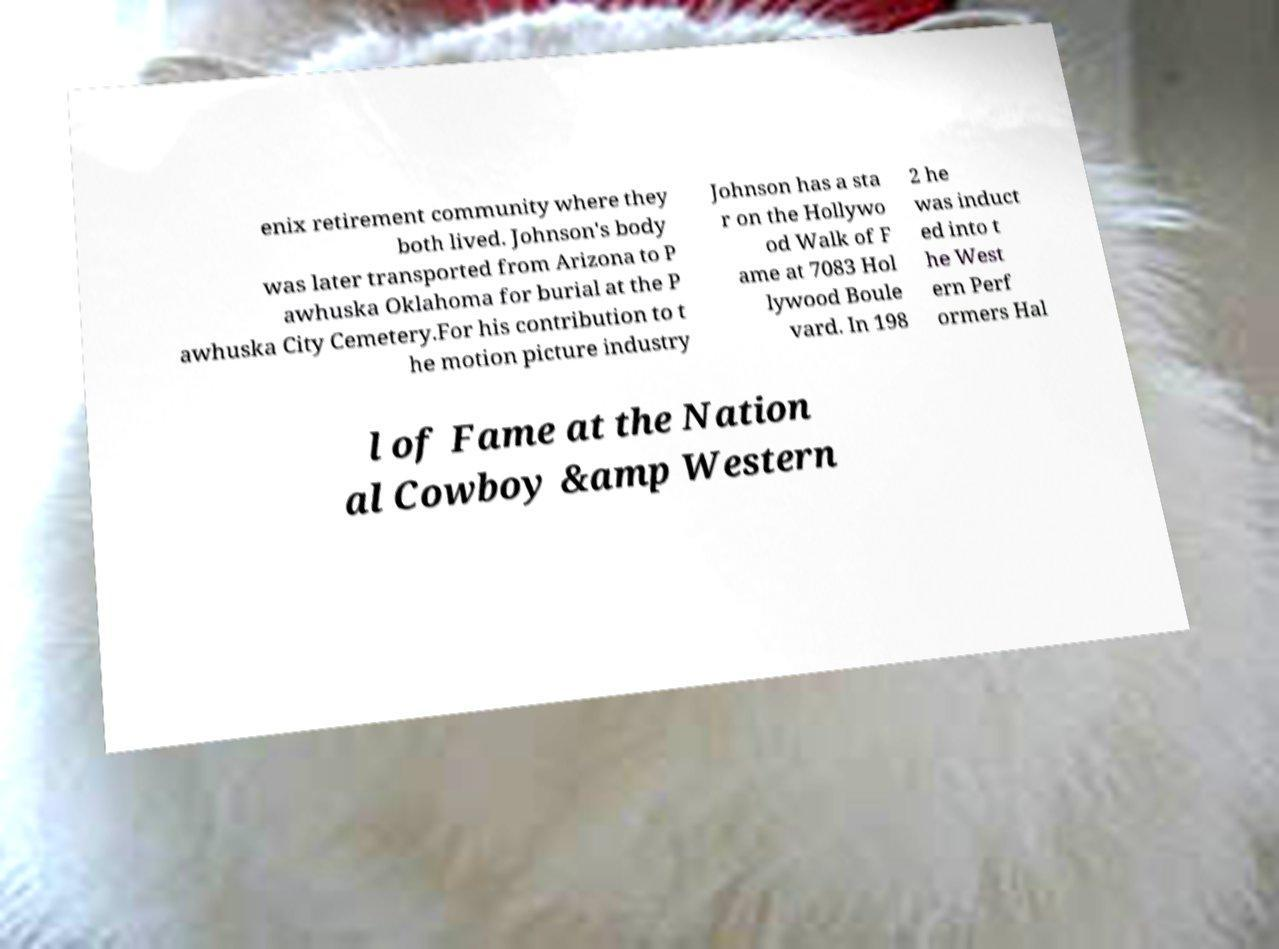I need the written content from this picture converted into text. Can you do that? enix retirement community where they both lived. Johnson's body was later transported from Arizona to P awhuska Oklahoma for burial at the P awhuska City Cemetery.For his contribution to t he motion picture industry Johnson has a sta r on the Hollywo od Walk of F ame at 7083 Hol lywood Boule vard. In 198 2 he was induct ed into t he West ern Perf ormers Hal l of Fame at the Nation al Cowboy &amp Western 